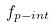Convert formula to latex. <formula><loc_0><loc_0><loc_500><loc_500>f _ { p - i n t }</formula> 